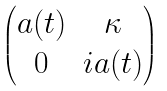Convert formula to latex. <formula><loc_0><loc_0><loc_500><loc_500>\begin{pmatrix} a ( t ) & \kappa \\ 0 & i a ( t ) \end{pmatrix}</formula> 